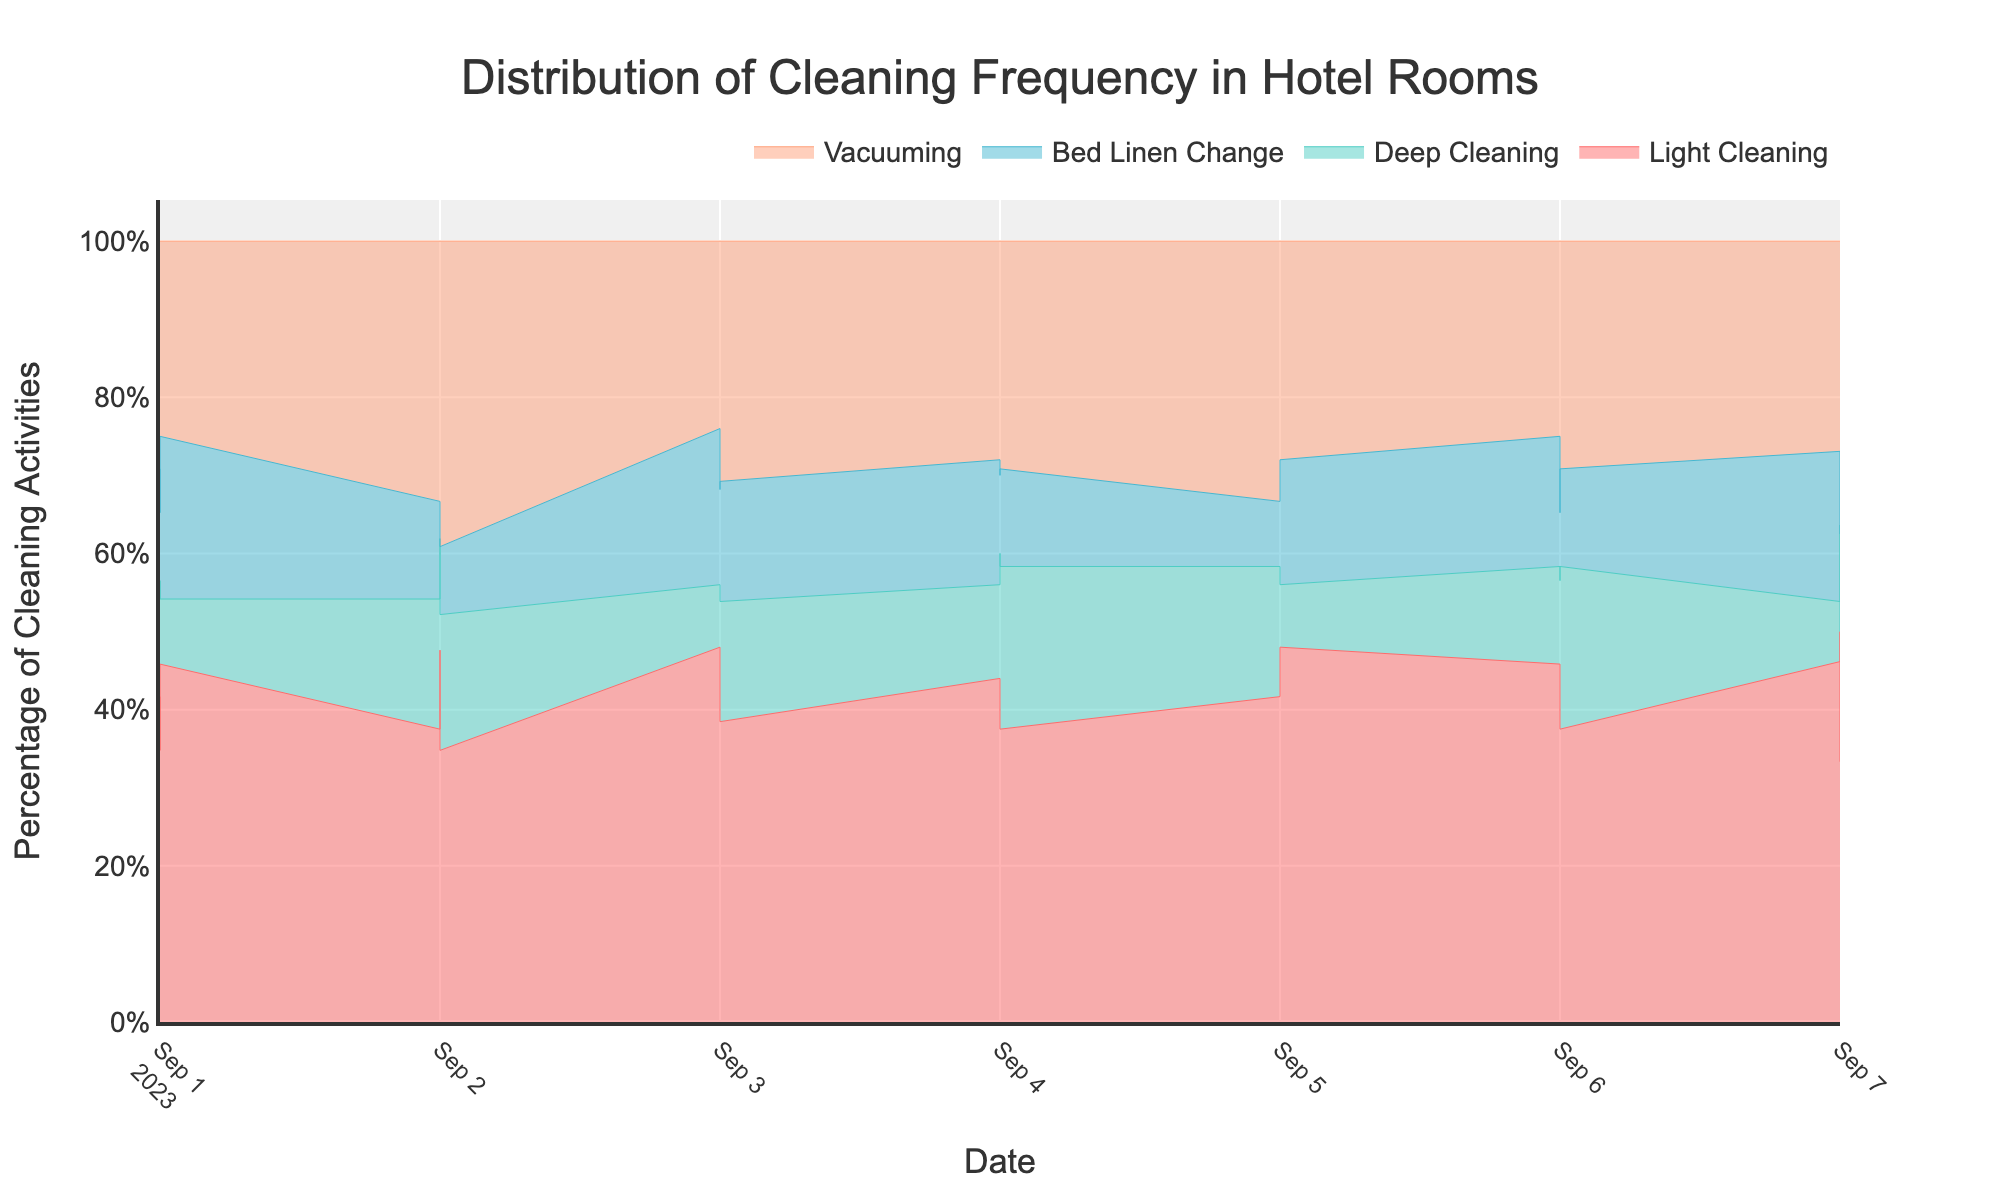What is the title of the figure? The title is usually placed at the top of a figure and is labeled in a larger, bold font to stand out. Look for the text that appears centered above everything else.
Answer: Distribution of Cleaning Frequency in Hotel Rooms How many types of cleaning activities are displayed in the figure? Count the different categories or legends listed in the figure, each corresponding to a type of cleaning activity.
Answer: Four Which cleaning activity appears to change the most over the days shown in the figure? Look at how much each activity's area varies over the days. The more it fluctuates in size, the more it changes.
Answer: Vacuuming On which date did Team Beta have the highest percentage of cleaning activities? Look at the stream graph's partition for Team Beta. Identify the peak day for their total activity across all types by observing the size of the corresponding area.
Answer: 2023-09-07 What is the most common housekeeping team in terms of overall cleaning frequency throughout the time period? Sum up the areas of all activities for each team. The team that has the largest combined area will be the most common.
Answer: Team Alpha What percentage of cleaning activities was dedicated to Light Cleaning on 2023-09-07? Focus specifically on the segment for Light Cleaning on 2023-09-07 and look at the percentage indicated by the height of the stack at that date.
Answer: About 40% Which housekeeping team had the smallest percentage of Deep Cleaning on 2023-09-04? Compare the sections labeled 'Deep Cleaning' across the teams on 2023-09-04 based on their relative heights within the stack.
Answer: Team Alpha Between Team Beta and Team Gamma, which team had more consistent Bed Linen Change frequencies over the dates? Examine the stream graph sections representing Bed Linen Change for Team Beta and Team Gamma. Note which section shows fewer and smaller fluctuations over the period.
Answer: Team Beta If you average the frequency of Deep Cleaning across all housekeeping teams on 2023-09-03, what value do you get? Add the Deep Cleaning frequencies for all teams on 2023-09-03, then divide by the number of teams. (2 + 3 + 4) / 3 = 3
Answer: 3 In total, which cleaning activity is performed the least over the period indicated in the graph? Sum up the frequencies of each cleaning activity individually across all dates and identify which one has the lowest total.
Answer: Bed Linen Change 